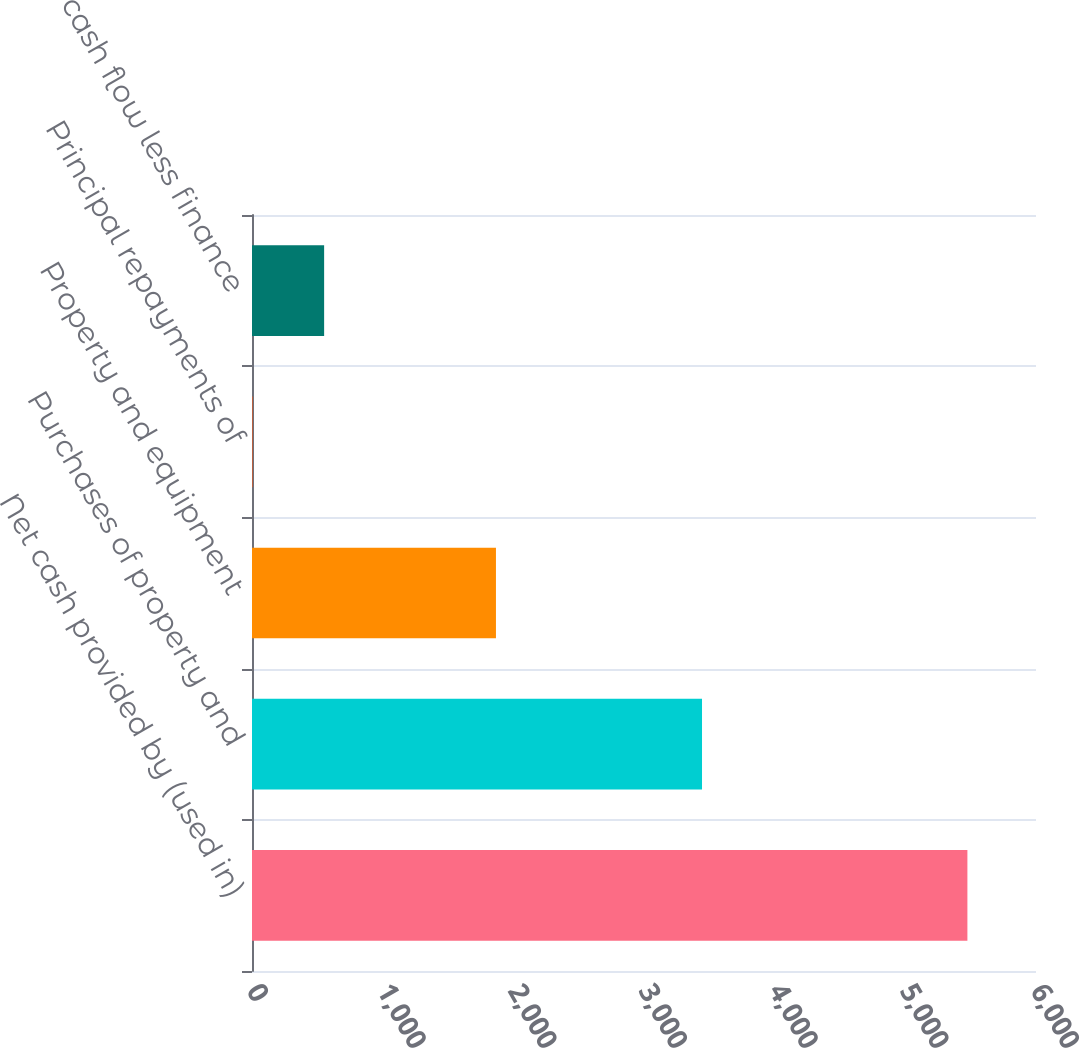<chart> <loc_0><loc_0><loc_500><loc_500><bar_chart><fcel>Net cash provided by (used in)<fcel>Purchases of property and<fcel>Property and equipment<fcel>Principal repayments of<fcel>Free cash flow less finance<nl><fcel>5475<fcel>3444<fcel>1867<fcel>5<fcel>552<nl></chart> 